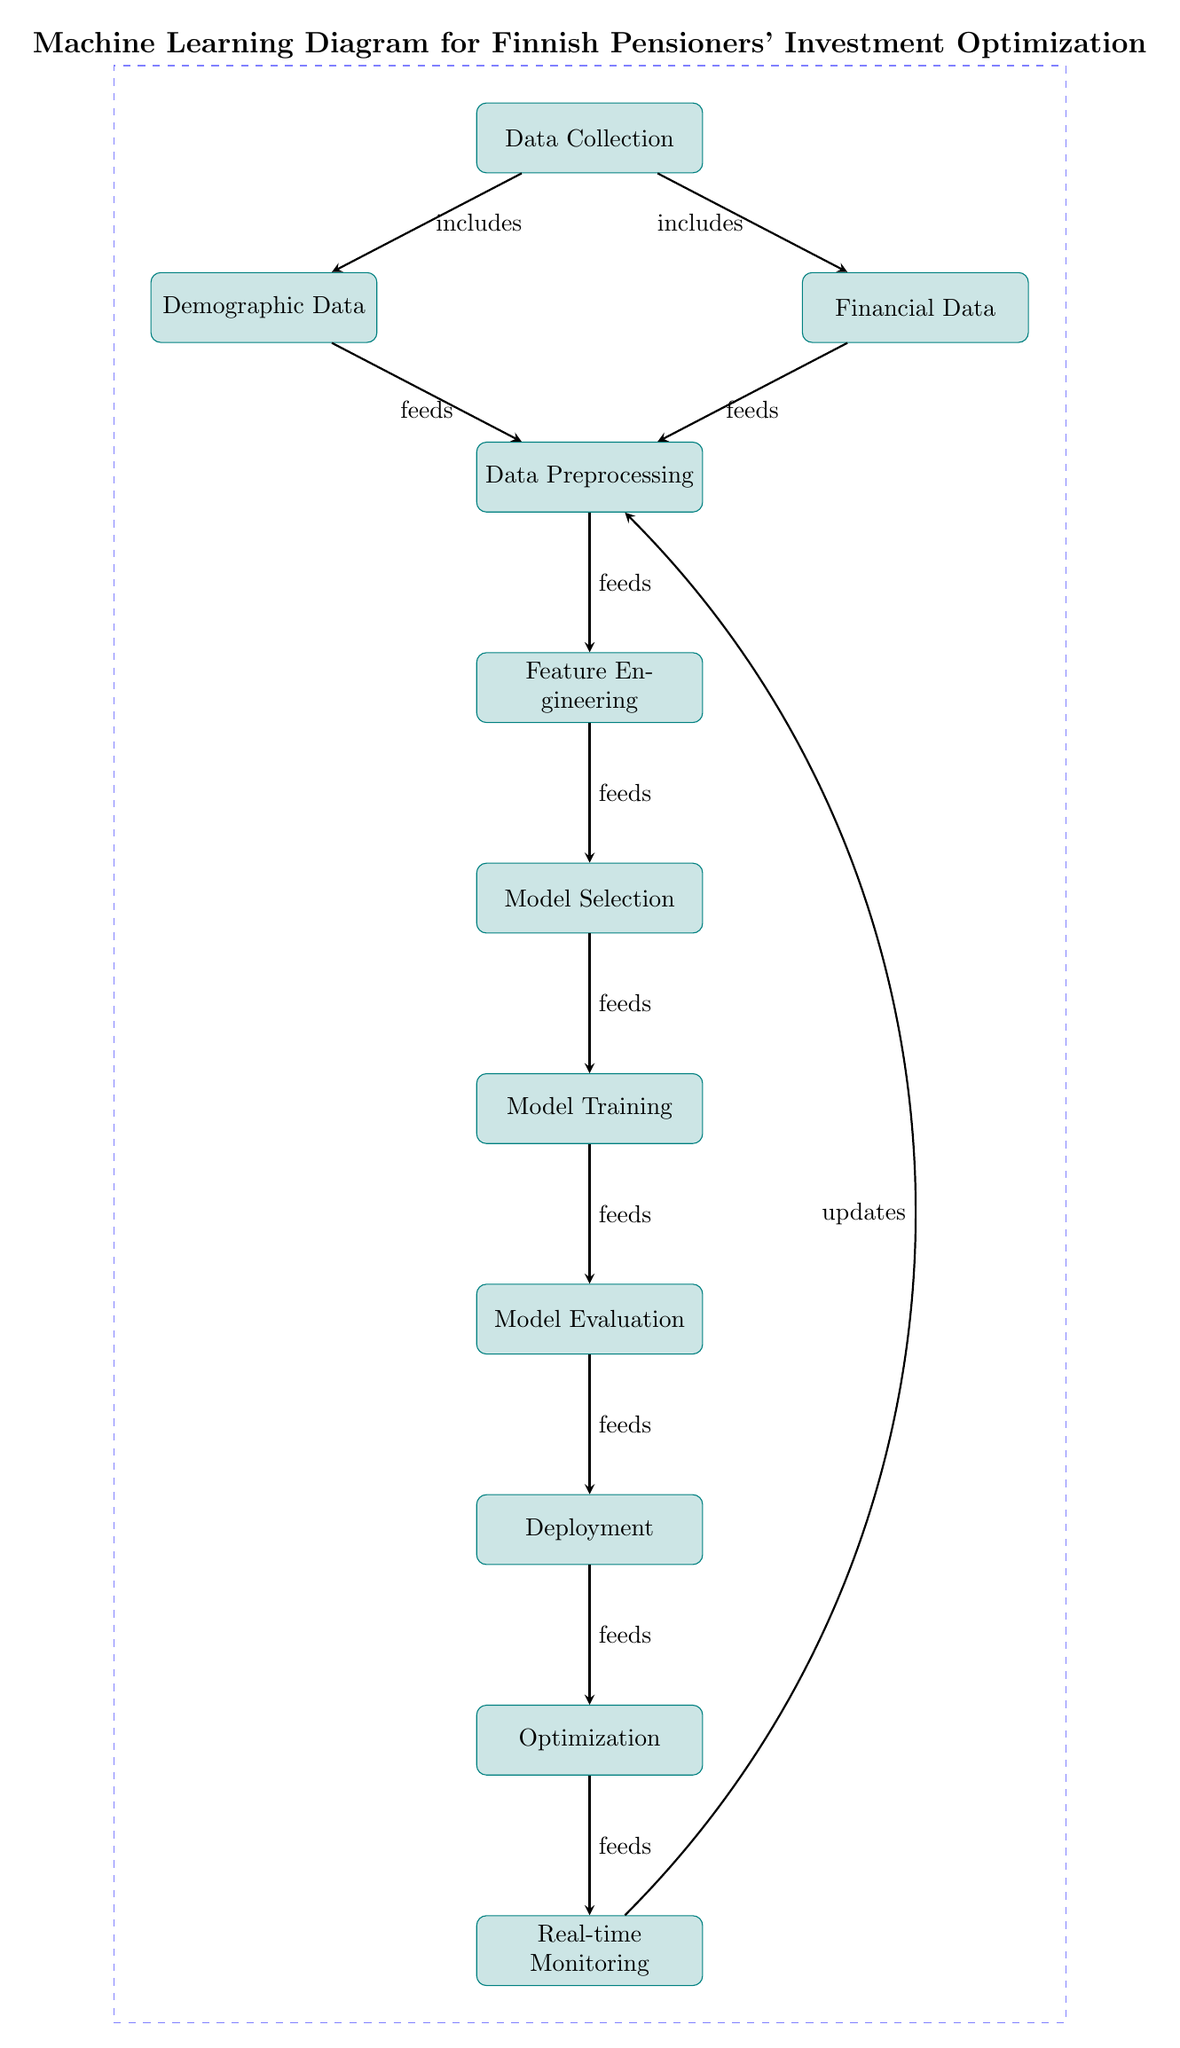What is the first step shown in the diagram? The first step is labeled as "Data Collection," which is the starting point of the process outlined in the diagram.
Answer: Data Collection How many main processes are there in the diagram? By counting the nodes labeled with distinct processes, we see there are 11 main processes listed in the diagram.
Answer: 11 Which two types of data are included in the data collection? The diagram identifies two types of data: "Demographic Data" and "Financial Data," which both fall under the broader category of data collection.
Answer: Demographic Data, Financial Data What step comes after "Model Evaluation"? Following the "Model Evaluation" step in the diagram, the next process is "Deployment." This relationship shows the flow of processes towards the end goal.
Answer: Deployment Which process feeds into "Feature Engineering"? The process of "Data Preprocessing" feeds into "Feature Engineering," indicating that preprocessing is crucial for feature extraction in the optimization task.
Answer: Data Preprocessing What is the final step outlined in the diagram? The last process described in the diagram is "Real-time Monitoring," which suggests ongoing oversight after deployment of the model.
Answer: Real-time Monitoring Which process loops back to "Data Preprocessing"? The "Real-time Monitoring" process updates and feeds back into "Data Preprocessing," indicating a feedback mechanism to refine the data being processed.
Answer: Real-time Monitoring What is the relationship between "Model Selection" and "Model Training"? The diagram shows that "Model Selection" feeds into "Model Training," which implies that after selecting a model, the next step is to train that model with the prepared data.
Answer: Model Selection feeds Model Training 